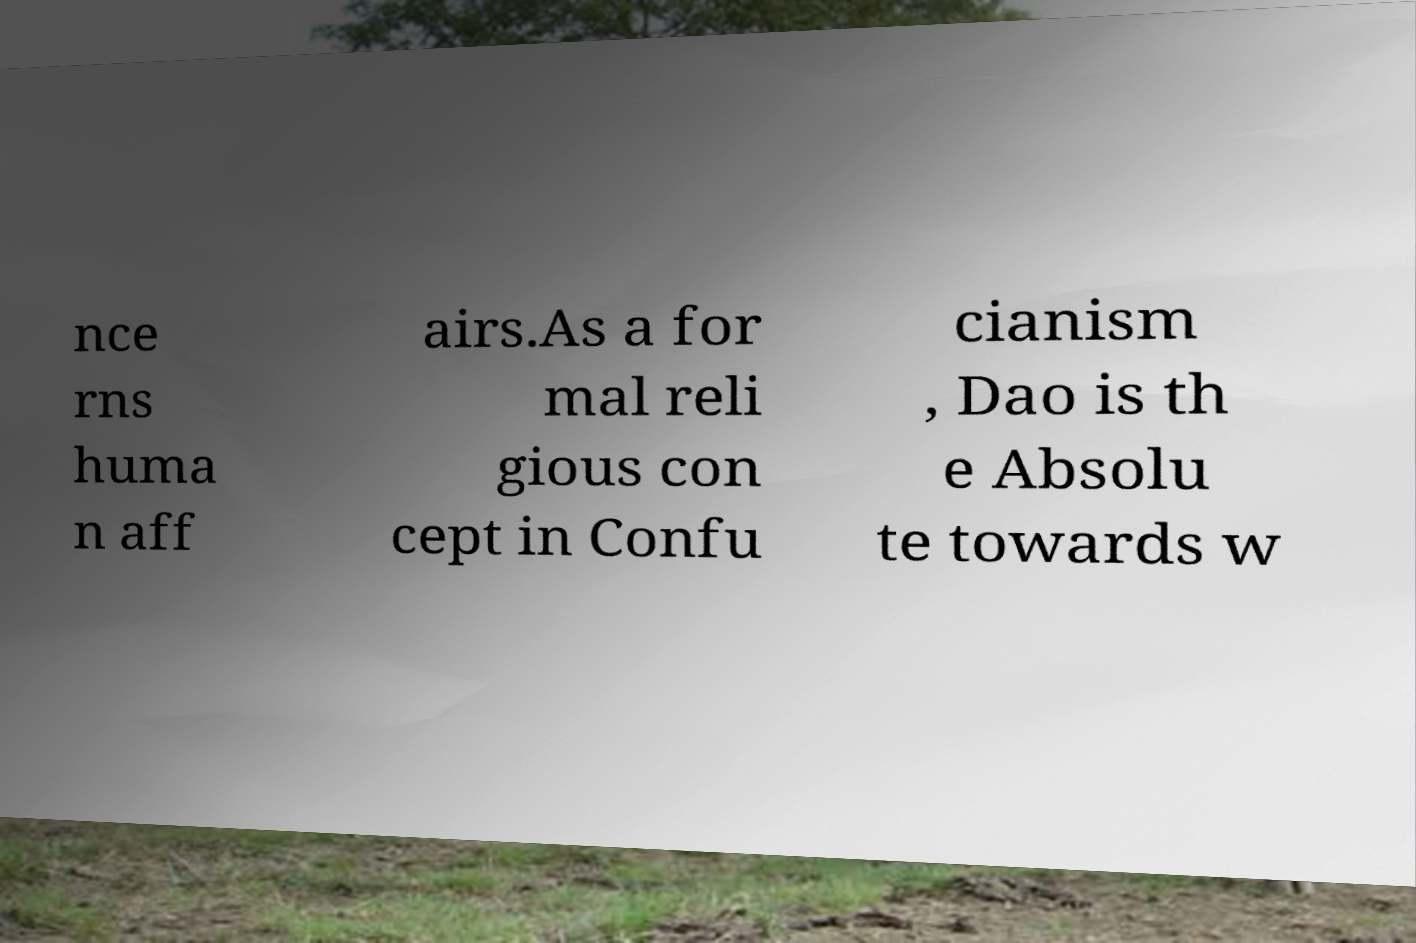Please read and relay the text visible in this image. What does it say? nce rns huma n aff airs.As a for mal reli gious con cept in Confu cianism , Dao is th e Absolu te towards w 